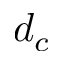Convert formula to latex. <formula><loc_0><loc_0><loc_500><loc_500>d _ { c }</formula> 